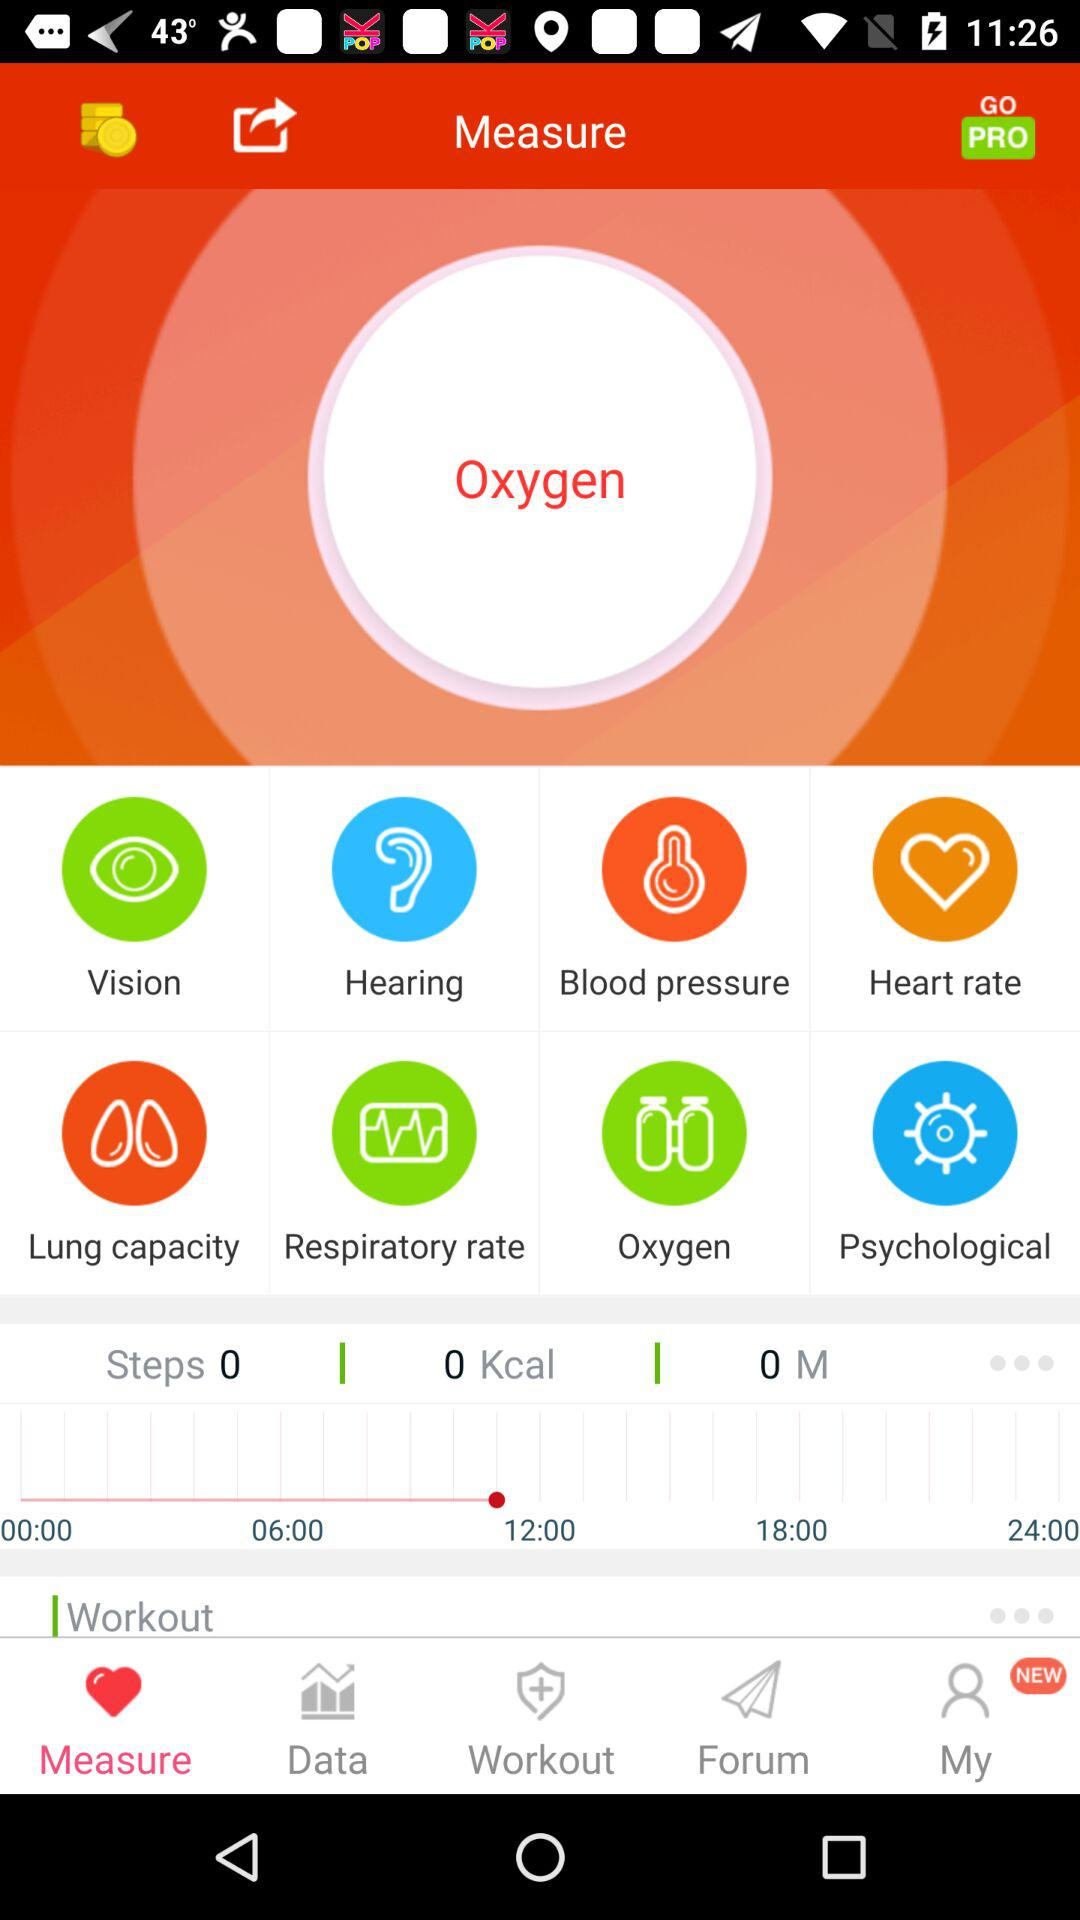What is the number of steps? There are 0 steps. 